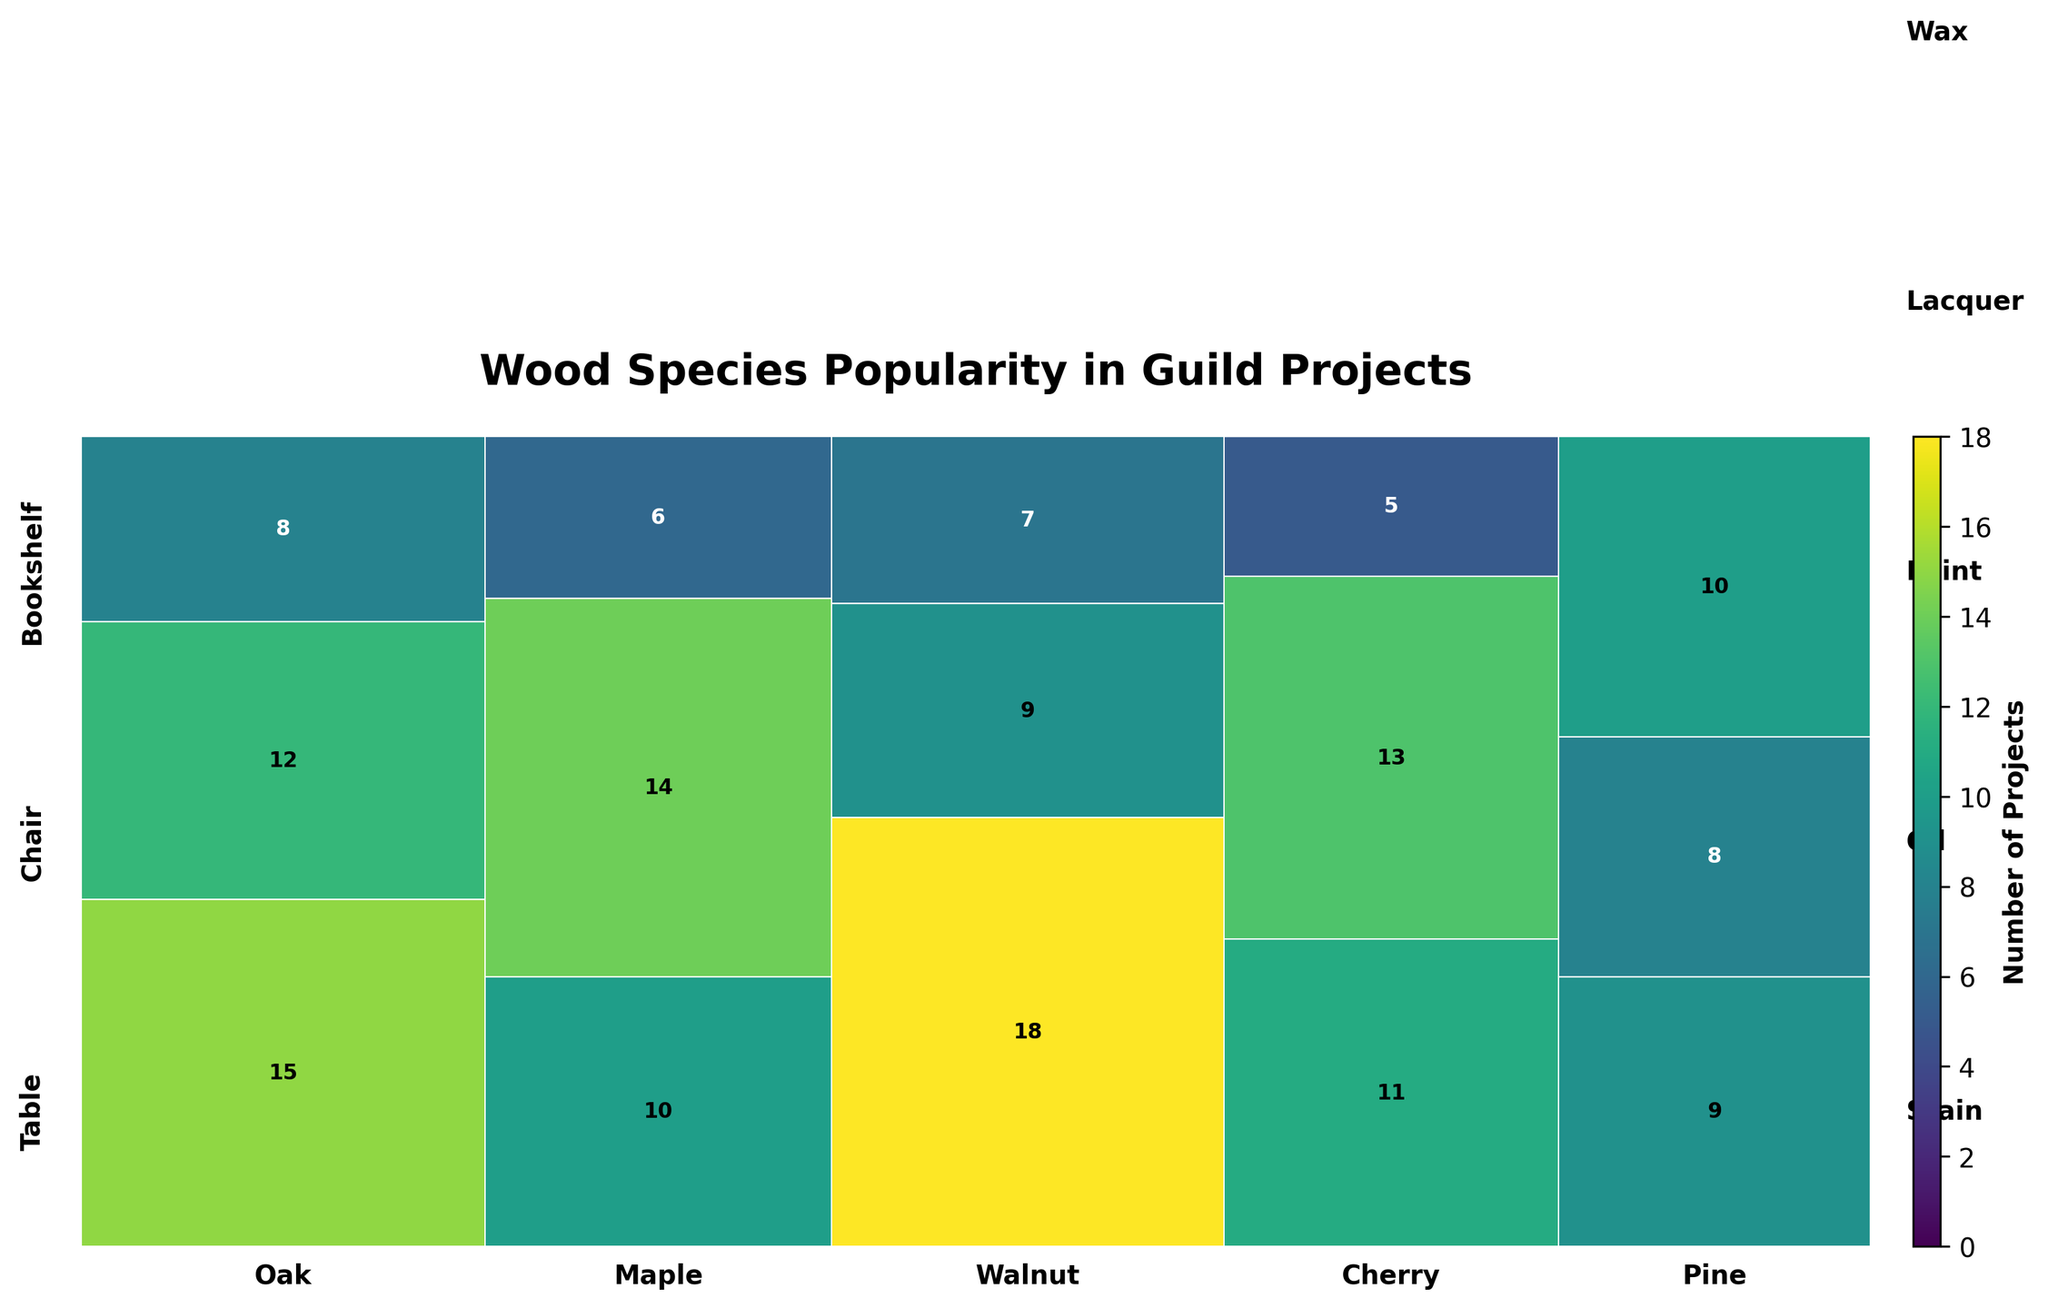How many projects use Oak wood for tables? Look for the section labeled "Oak" and then find the part corresponding to "Table". Read the number in the center of that section.
Answer: 15 Which wood species has the most projects overall? Sum the projects for each wood species by adding up the numbers in all sections corresponding to each wood. Oak has 35 (15 + 12 + 8), Maple has 30 (10 + 14 + 6), Walnut has 34 (18 + 9 + 7), Cherry has 29 (11 + 13 + 5), Pine has 27 (9 + 8 + 10). Oak has the highest total.
Answer: Oak Which finishing method is the least common for bookshelves? Examine each section labeled "Bookshelf" for all wood species and identify the finishing method with the smallest total projects. The numbers for finishing methods are: Paint (Oak, 8), Lacquer (Maple, 6), Wax (Walnut, 7), Stain (Cherry, 5), Oil (Pine, 10). Stain is the least common.
Answer: Stain What is the total number of projects using the oil finishing method? Add up all the project numbers for sections labeled "Oil". Oak (12 for Chair), Maple (10 for Table), Walnut (18 for Table), Cherry (13 for Chair), Pine (10 for Bookshelf). 12 + 10 + 18 + 13 + 10 = 63.
Answer: 63 Is there any wood species that isn't used for bookshelves? Check every section for "Bookshelf" and see if a wood species is missing a corresponding section. Each wood (Oak, Maple, Walnut, Cherry, Pine) has at least one project for bookshelves.
Answer: No Which furniture type and finishing method combination is the most common for Walnut wood? Look at the "Walnut" section and find the combination with the highest number. For Walnut, we have Table (Oil, 18), Chair (Stain, 9), Bookshelf (Wax, 7). The highest number is 18 for Table with Oil.
Answer: Table with Oil Compare the number of projects for Pine wood finished with paint and wax. Which is higher? Look at the "Pine" section and check the numbers for "Paint" and "Wax". Pine Table with Paint has 9, and Pine Chair with Wax has 8. Paint is higher.
Answer: Paint How many more projects use Cherry wood compared to Pine wood? Calculate the total number of projects for Cherry (11 + 13 + 5 = 29) and Pine (9 + 8 + 10 = 27). The difference is 29 - 27.
Answer: 2 What is the average number of projects for Maple chairs across all finishing methods? Add the number of projects for Maple chairs (14 for Stain) and calculate the average (since there's only one type for Maple Chair, the average is 14).
Answer: 14 